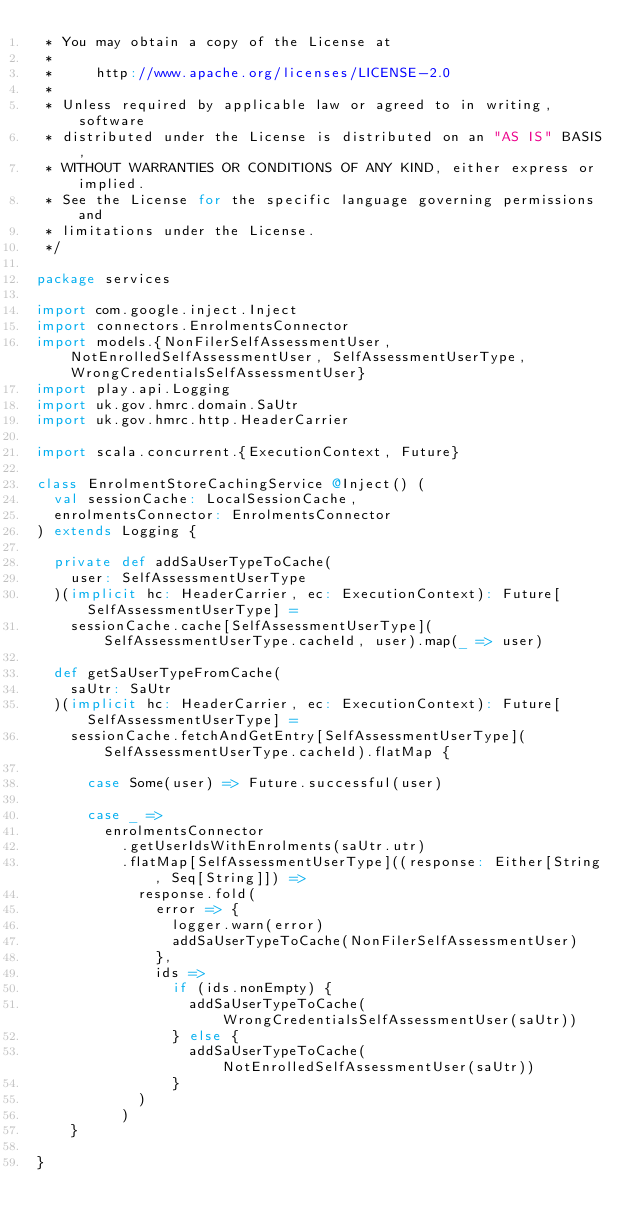Convert code to text. <code><loc_0><loc_0><loc_500><loc_500><_Scala_> * You may obtain a copy of the License at
 *
 *     http://www.apache.org/licenses/LICENSE-2.0
 *
 * Unless required by applicable law or agreed to in writing, software
 * distributed under the License is distributed on an "AS IS" BASIS,
 * WITHOUT WARRANTIES OR CONDITIONS OF ANY KIND, either express or implied.
 * See the License for the specific language governing permissions and
 * limitations under the License.
 */

package services

import com.google.inject.Inject
import connectors.EnrolmentsConnector
import models.{NonFilerSelfAssessmentUser, NotEnrolledSelfAssessmentUser, SelfAssessmentUserType, WrongCredentialsSelfAssessmentUser}
import play.api.Logging
import uk.gov.hmrc.domain.SaUtr
import uk.gov.hmrc.http.HeaderCarrier

import scala.concurrent.{ExecutionContext, Future}

class EnrolmentStoreCachingService @Inject() (
  val sessionCache: LocalSessionCache,
  enrolmentsConnector: EnrolmentsConnector
) extends Logging {

  private def addSaUserTypeToCache(
    user: SelfAssessmentUserType
  )(implicit hc: HeaderCarrier, ec: ExecutionContext): Future[SelfAssessmentUserType] =
    sessionCache.cache[SelfAssessmentUserType](SelfAssessmentUserType.cacheId, user).map(_ => user)

  def getSaUserTypeFromCache(
    saUtr: SaUtr
  )(implicit hc: HeaderCarrier, ec: ExecutionContext): Future[SelfAssessmentUserType] =
    sessionCache.fetchAndGetEntry[SelfAssessmentUserType](SelfAssessmentUserType.cacheId).flatMap {

      case Some(user) => Future.successful(user)

      case _ =>
        enrolmentsConnector
          .getUserIdsWithEnrolments(saUtr.utr)
          .flatMap[SelfAssessmentUserType]((response: Either[String, Seq[String]]) =>
            response.fold(
              error => {
                logger.warn(error)
                addSaUserTypeToCache(NonFilerSelfAssessmentUser)
              },
              ids =>
                if (ids.nonEmpty) {
                  addSaUserTypeToCache(WrongCredentialsSelfAssessmentUser(saUtr))
                } else {
                  addSaUserTypeToCache(NotEnrolledSelfAssessmentUser(saUtr))
                }
            )
          )
    }

}
</code> 